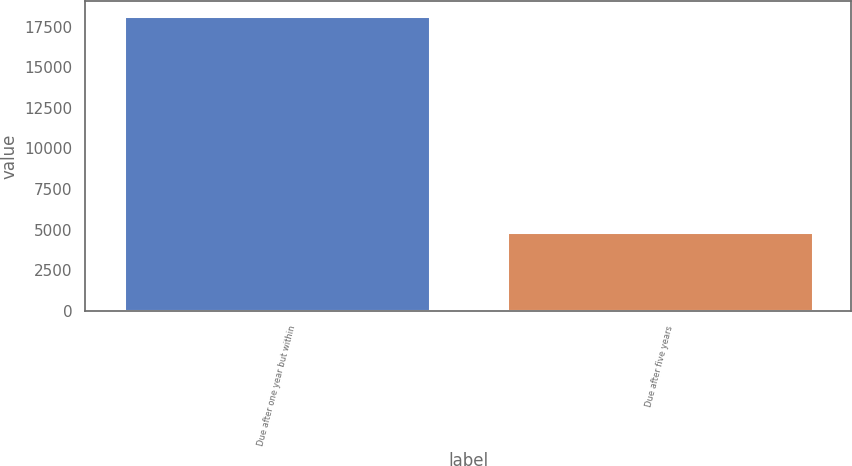Convert chart. <chart><loc_0><loc_0><loc_500><loc_500><bar_chart><fcel>Due after one year but within<fcel>Due after five years<nl><fcel>18167<fcel>4848<nl></chart> 